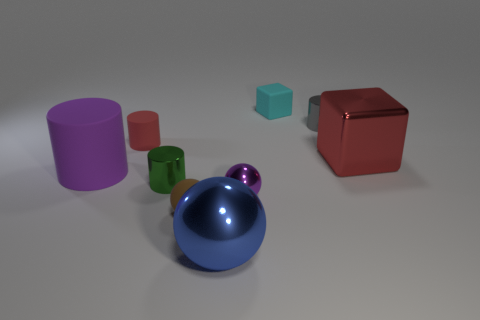There is a metallic thing that is the same color as the large cylinder; what is its shape?
Give a very brief answer. Sphere. How many spheres are either green things or shiny objects?
Ensure brevity in your answer.  2. There is a small metallic object that is behind the big object that is on the left side of the blue object; what color is it?
Your response must be concise. Gray. There is a metallic block; is its color the same as the matte cylinder that is behind the red metal block?
Make the answer very short. Yes. There is a cube that is made of the same material as the large blue object; what size is it?
Your response must be concise. Large. What is the size of the cylinder that is the same color as the big block?
Your answer should be compact. Small. Does the metal cube have the same color as the tiny matte cylinder?
Your answer should be very brief. Yes. Are there any red objects behind the big metal thing that is behind the large metal object that is in front of the tiny green cylinder?
Your answer should be very brief. Yes. How many gray matte objects have the same size as the brown rubber object?
Your response must be concise. 0. Do the metallic cylinder that is in front of the red metallic block and the metallic cylinder that is behind the big red shiny thing have the same size?
Your answer should be very brief. Yes. 